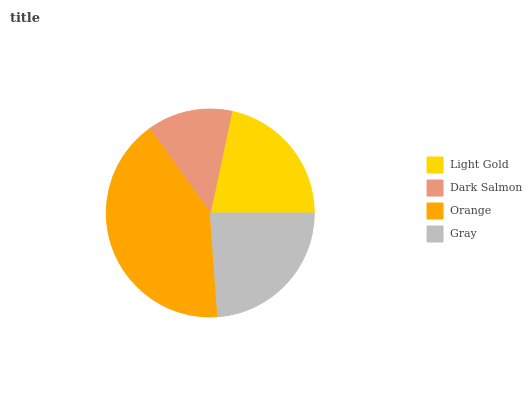Is Dark Salmon the minimum?
Answer yes or no. Yes. Is Orange the maximum?
Answer yes or no. Yes. Is Orange the minimum?
Answer yes or no. No. Is Dark Salmon the maximum?
Answer yes or no. No. Is Orange greater than Dark Salmon?
Answer yes or no. Yes. Is Dark Salmon less than Orange?
Answer yes or no. Yes. Is Dark Salmon greater than Orange?
Answer yes or no. No. Is Orange less than Dark Salmon?
Answer yes or no. No. Is Gray the high median?
Answer yes or no. Yes. Is Light Gold the low median?
Answer yes or no. Yes. Is Orange the high median?
Answer yes or no. No. Is Dark Salmon the low median?
Answer yes or no. No. 